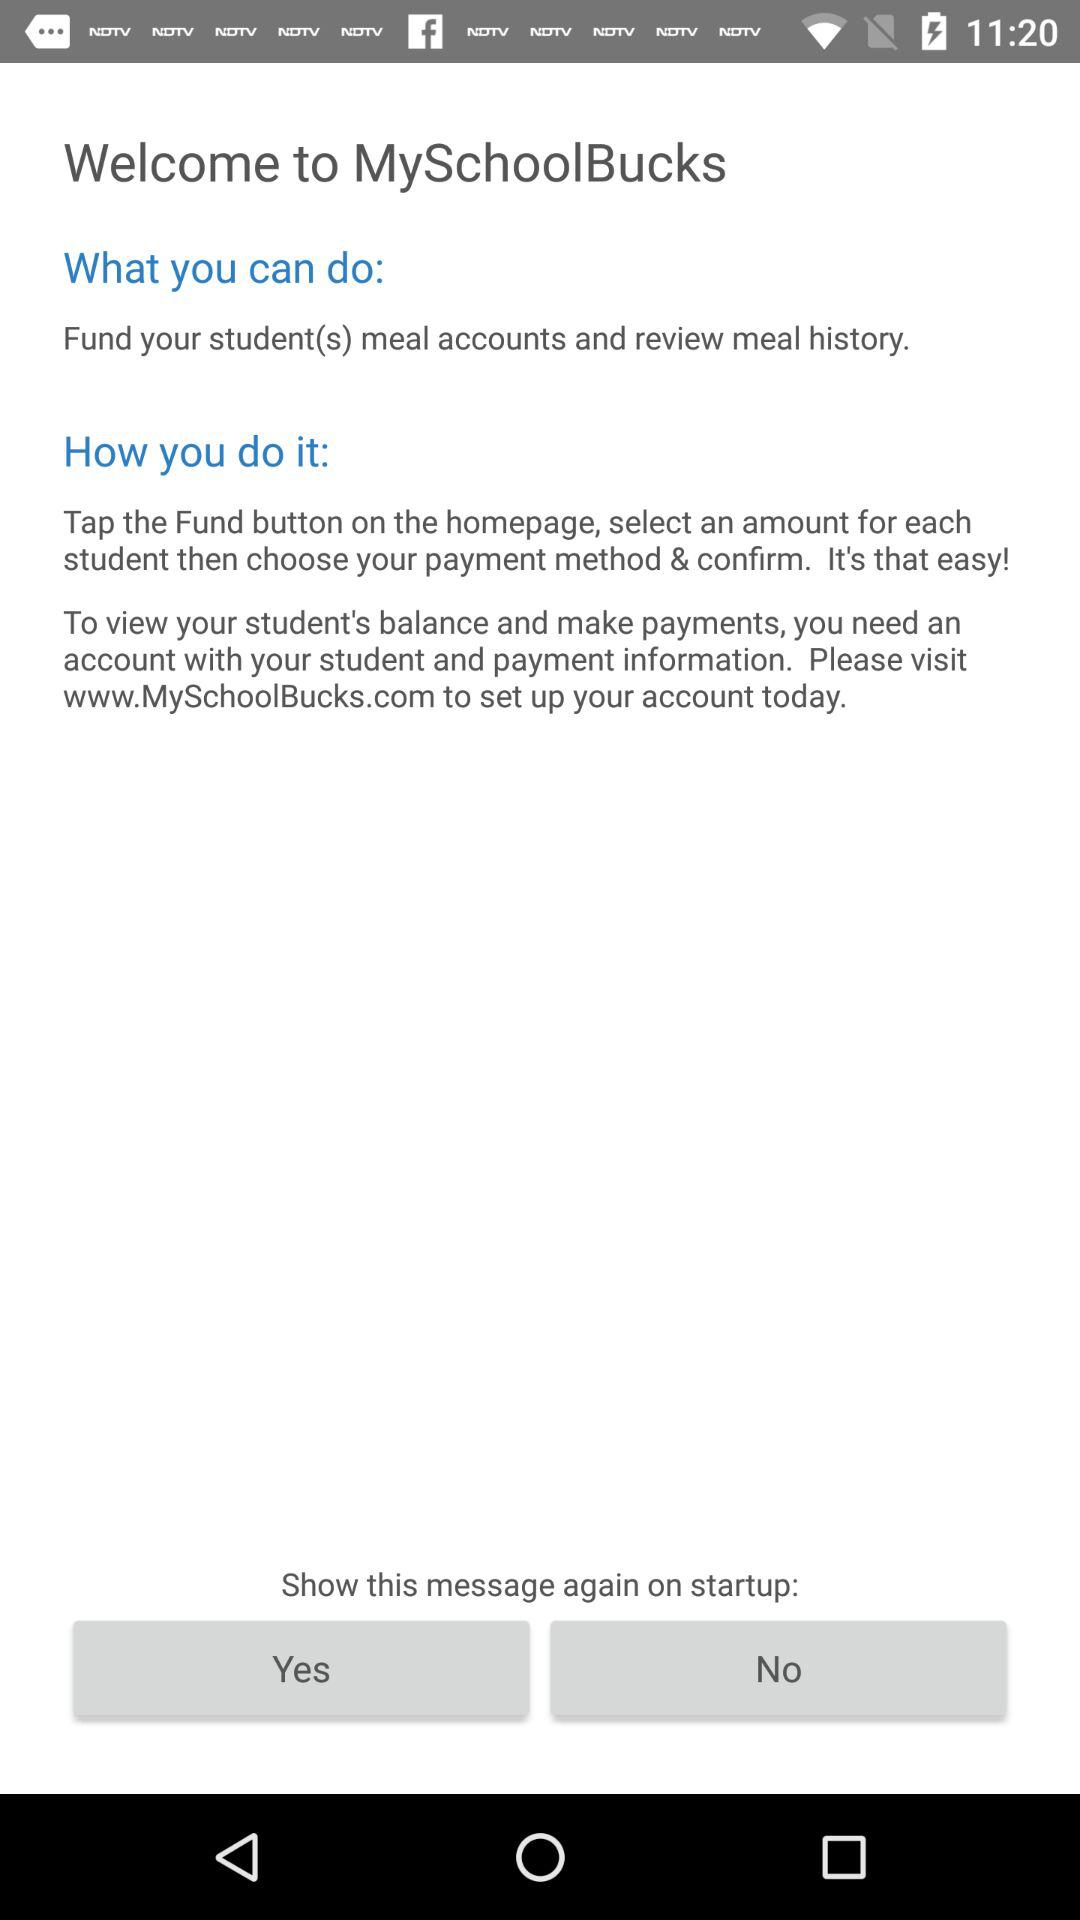How many actions can I do with MySchoolBucks?
Answer the question using a single word or phrase. 2 